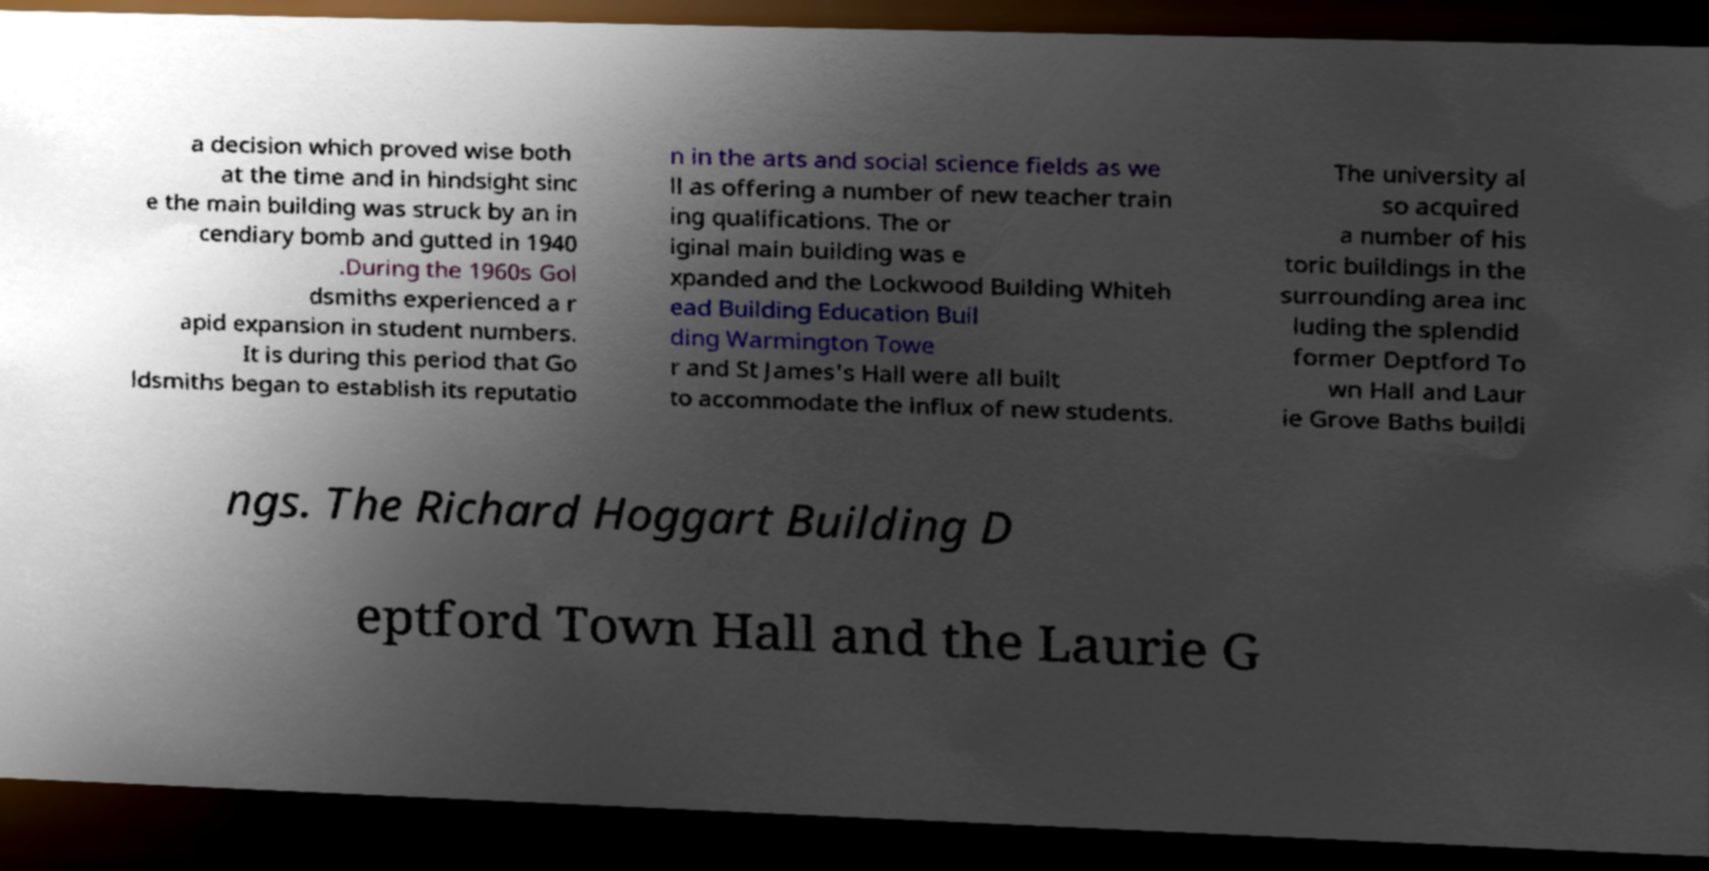Could you assist in decoding the text presented in this image and type it out clearly? a decision which proved wise both at the time and in hindsight sinc e the main building was struck by an in cendiary bomb and gutted in 1940 .During the 1960s Gol dsmiths experienced a r apid expansion in student numbers. It is during this period that Go ldsmiths began to establish its reputatio n in the arts and social science fields as we ll as offering a number of new teacher train ing qualifications. The or iginal main building was e xpanded and the Lockwood Building Whiteh ead Building Education Buil ding Warmington Towe r and St James's Hall were all built to accommodate the influx of new students. The university al so acquired a number of his toric buildings in the surrounding area inc luding the splendid former Deptford To wn Hall and Laur ie Grove Baths buildi ngs. The Richard Hoggart Building D eptford Town Hall and the Laurie G 